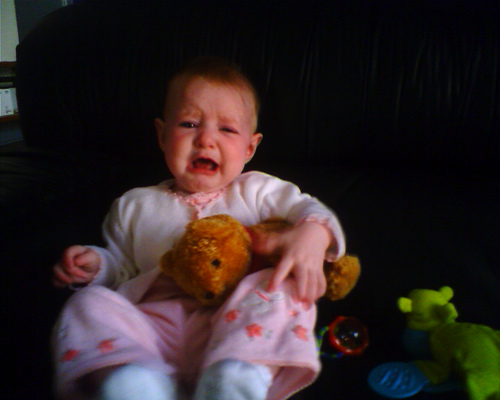What is the little girl sitting in? The little girl is sitting in a high chair designed for feeding infants and toddlers. The chair is equipped with a cover, and she is surrounded by various toys, indicating the high chair is placed in a living area, likely for comfort and interaction. 